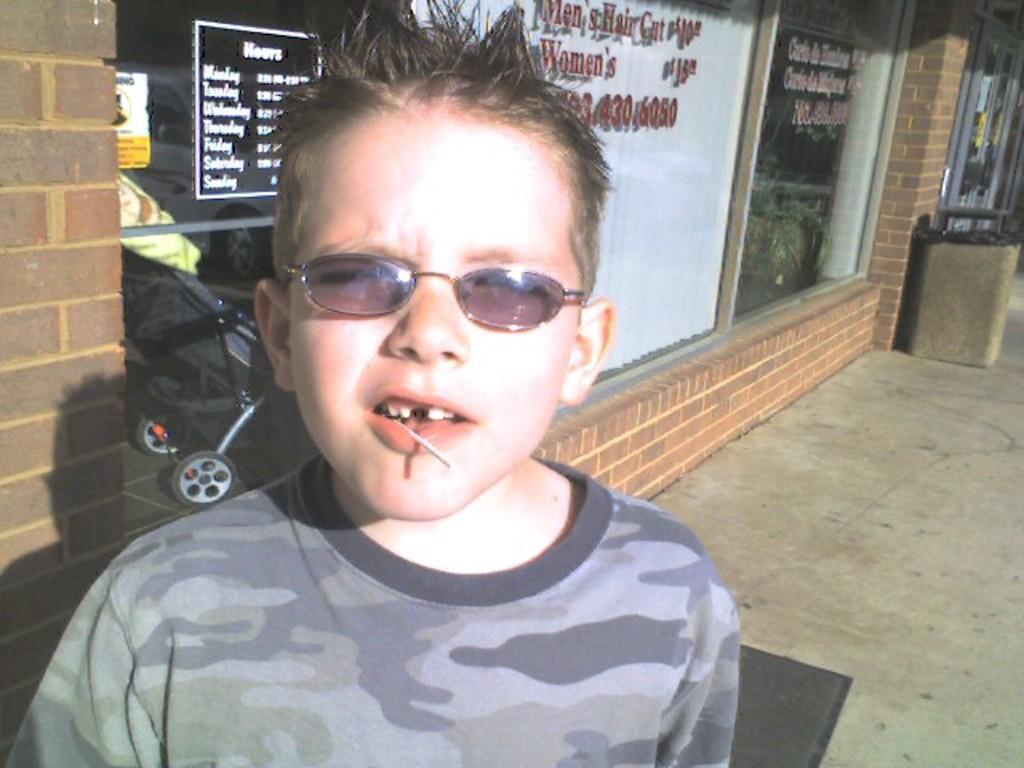Could you give a brief overview of what you see in this image? This image is taken outdoors. At the bottom of the image there is a floor and there is a mat. In the middle of the image there is a kid. In the background there is a building with a few walls and glass doors. There are a few boards with text on them and there is a dustbin. 